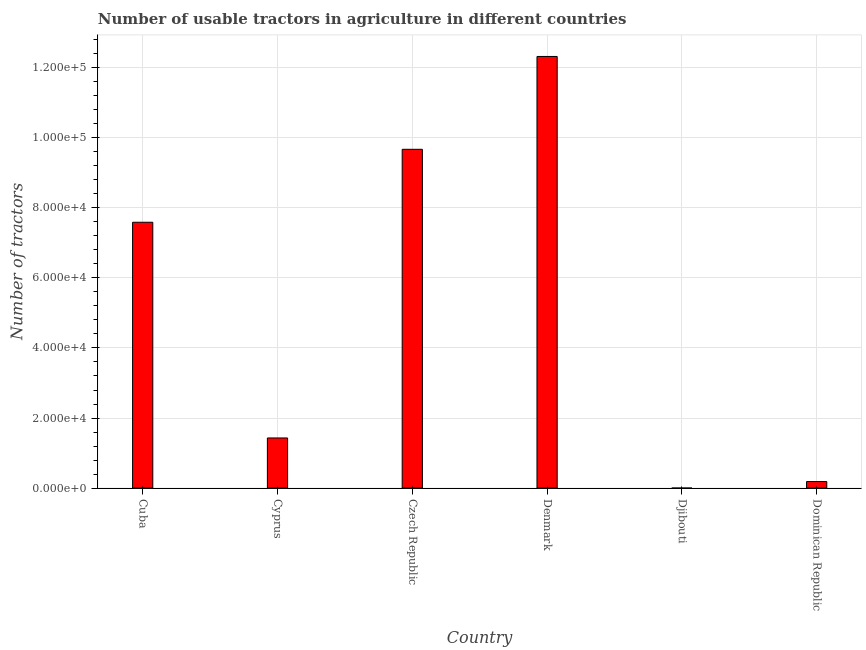Does the graph contain grids?
Offer a very short reply. Yes. What is the title of the graph?
Give a very brief answer. Number of usable tractors in agriculture in different countries. What is the label or title of the X-axis?
Your answer should be very brief. Country. What is the label or title of the Y-axis?
Provide a short and direct response. Number of tractors. What is the number of tractors in Cuba?
Give a very brief answer. 7.59e+04. Across all countries, what is the maximum number of tractors?
Give a very brief answer. 1.23e+05. Across all countries, what is the minimum number of tractors?
Your answer should be very brief. 8. In which country was the number of tractors minimum?
Your answer should be compact. Djibouti. What is the sum of the number of tractors?
Ensure brevity in your answer.  3.12e+05. What is the difference between the number of tractors in Czech Republic and Djibouti?
Make the answer very short. 9.67e+04. What is the average number of tractors per country?
Ensure brevity in your answer.  5.20e+04. What is the median number of tractors?
Keep it short and to the point. 4.51e+04. What is the ratio of the number of tractors in Cuba to that in Djibouti?
Provide a short and direct response. 9485.88. Is the number of tractors in Cyprus less than that in Dominican Republic?
Offer a very short reply. No. Is the difference between the number of tractors in Cuba and Djibouti greater than the difference between any two countries?
Provide a succinct answer. No. What is the difference between the highest and the second highest number of tractors?
Ensure brevity in your answer.  2.65e+04. Is the sum of the number of tractors in Czech Republic and Djibouti greater than the maximum number of tractors across all countries?
Give a very brief answer. No. What is the difference between the highest and the lowest number of tractors?
Make the answer very short. 1.23e+05. In how many countries, is the number of tractors greater than the average number of tractors taken over all countries?
Your answer should be compact. 3. How many bars are there?
Ensure brevity in your answer.  6. Are all the bars in the graph horizontal?
Give a very brief answer. No. What is the difference between two consecutive major ticks on the Y-axis?
Offer a very short reply. 2.00e+04. What is the Number of tractors of Cuba?
Offer a very short reply. 7.59e+04. What is the Number of tractors of Cyprus?
Offer a very short reply. 1.43e+04. What is the Number of tractors in Czech Republic?
Give a very brief answer. 9.67e+04. What is the Number of tractors of Denmark?
Offer a very short reply. 1.23e+05. What is the Number of tractors of Djibouti?
Give a very brief answer. 8. What is the Number of tractors of Dominican Republic?
Make the answer very short. 1868. What is the difference between the Number of tractors in Cuba and Cyprus?
Your response must be concise. 6.16e+04. What is the difference between the Number of tractors in Cuba and Czech Republic?
Your response must be concise. -2.08e+04. What is the difference between the Number of tractors in Cuba and Denmark?
Offer a very short reply. -4.73e+04. What is the difference between the Number of tractors in Cuba and Djibouti?
Your response must be concise. 7.59e+04. What is the difference between the Number of tractors in Cuba and Dominican Republic?
Make the answer very short. 7.40e+04. What is the difference between the Number of tractors in Cyprus and Czech Republic?
Your answer should be very brief. -8.24e+04. What is the difference between the Number of tractors in Cyprus and Denmark?
Keep it short and to the point. -1.09e+05. What is the difference between the Number of tractors in Cyprus and Djibouti?
Offer a terse response. 1.43e+04. What is the difference between the Number of tractors in Cyprus and Dominican Republic?
Offer a very short reply. 1.24e+04. What is the difference between the Number of tractors in Czech Republic and Denmark?
Offer a very short reply. -2.65e+04. What is the difference between the Number of tractors in Czech Republic and Djibouti?
Keep it short and to the point. 9.67e+04. What is the difference between the Number of tractors in Czech Republic and Dominican Republic?
Provide a short and direct response. 9.48e+04. What is the difference between the Number of tractors in Denmark and Djibouti?
Your answer should be compact. 1.23e+05. What is the difference between the Number of tractors in Denmark and Dominican Republic?
Give a very brief answer. 1.21e+05. What is the difference between the Number of tractors in Djibouti and Dominican Republic?
Offer a very short reply. -1860. What is the ratio of the Number of tractors in Cuba to that in Cyprus?
Your answer should be compact. 5.3. What is the ratio of the Number of tractors in Cuba to that in Czech Republic?
Your answer should be very brief. 0.79. What is the ratio of the Number of tractors in Cuba to that in Denmark?
Keep it short and to the point. 0.62. What is the ratio of the Number of tractors in Cuba to that in Djibouti?
Provide a short and direct response. 9485.88. What is the ratio of the Number of tractors in Cuba to that in Dominican Republic?
Your answer should be very brief. 40.62. What is the ratio of the Number of tractors in Cyprus to that in Czech Republic?
Your answer should be very brief. 0.15. What is the ratio of the Number of tractors in Cyprus to that in Denmark?
Offer a very short reply. 0.12. What is the ratio of the Number of tractors in Cyprus to that in Djibouti?
Keep it short and to the point. 1788.62. What is the ratio of the Number of tractors in Cyprus to that in Dominican Republic?
Your answer should be compact. 7.66. What is the ratio of the Number of tractors in Czech Republic to that in Denmark?
Your answer should be very brief. 0.79. What is the ratio of the Number of tractors in Czech Republic to that in Djibouti?
Ensure brevity in your answer.  1.21e+04. What is the ratio of the Number of tractors in Czech Republic to that in Dominican Republic?
Offer a terse response. 51.77. What is the ratio of the Number of tractors in Denmark to that in Djibouti?
Make the answer very short. 1.54e+04. What is the ratio of the Number of tractors in Denmark to that in Dominican Republic?
Your answer should be very brief. 65.96. What is the ratio of the Number of tractors in Djibouti to that in Dominican Republic?
Your answer should be very brief. 0. 